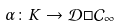Convert formula to latex. <formula><loc_0><loc_0><loc_500><loc_500>\alpha \colon K \rightarrow \mathcal { D } \Box \mathcal { C } _ { \infty }</formula> 